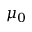<formula> <loc_0><loc_0><loc_500><loc_500>\mu _ { 0 }</formula> 